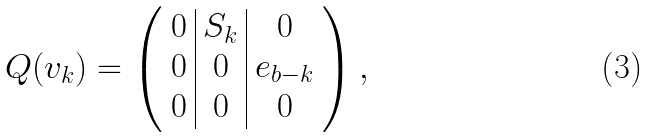Convert formula to latex. <formula><loc_0><loc_0><loc_500><loc_500>Q ( v _ { k } ) = \left ( \begin{array} { c | c | c } 0 & S _ { k } & 0 \\ 0 & 0 & e _ { b - k } \\ 0 & 0 & 0 \\ \end{array} \right ) ,</formula> 